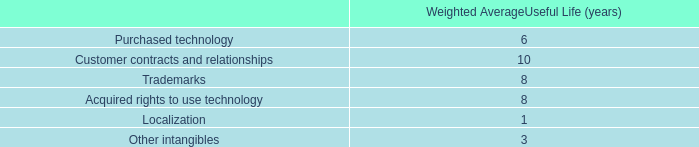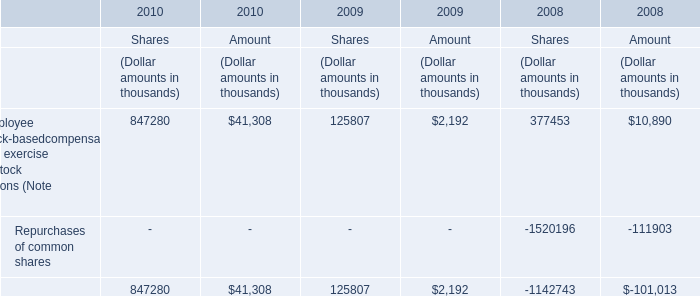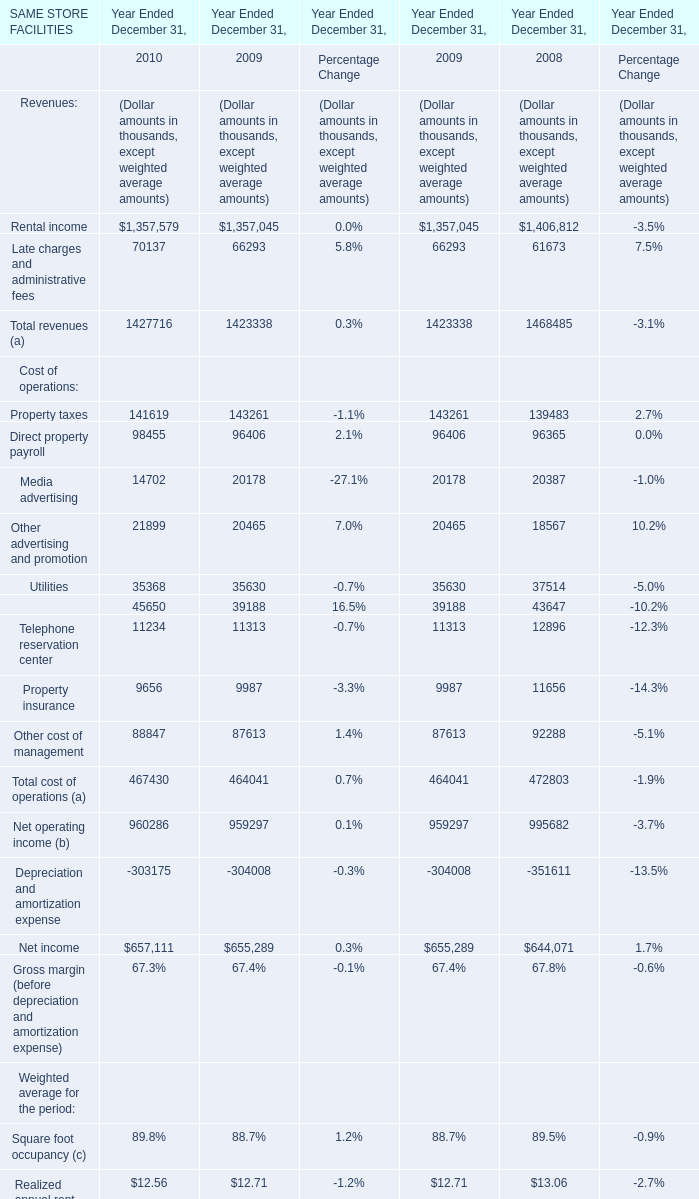What is the difference between the greatest Cost of operations in 2009 and 2008？ (in million) 
Computations: (143261 - 139483)
Answer: 3778.0. 